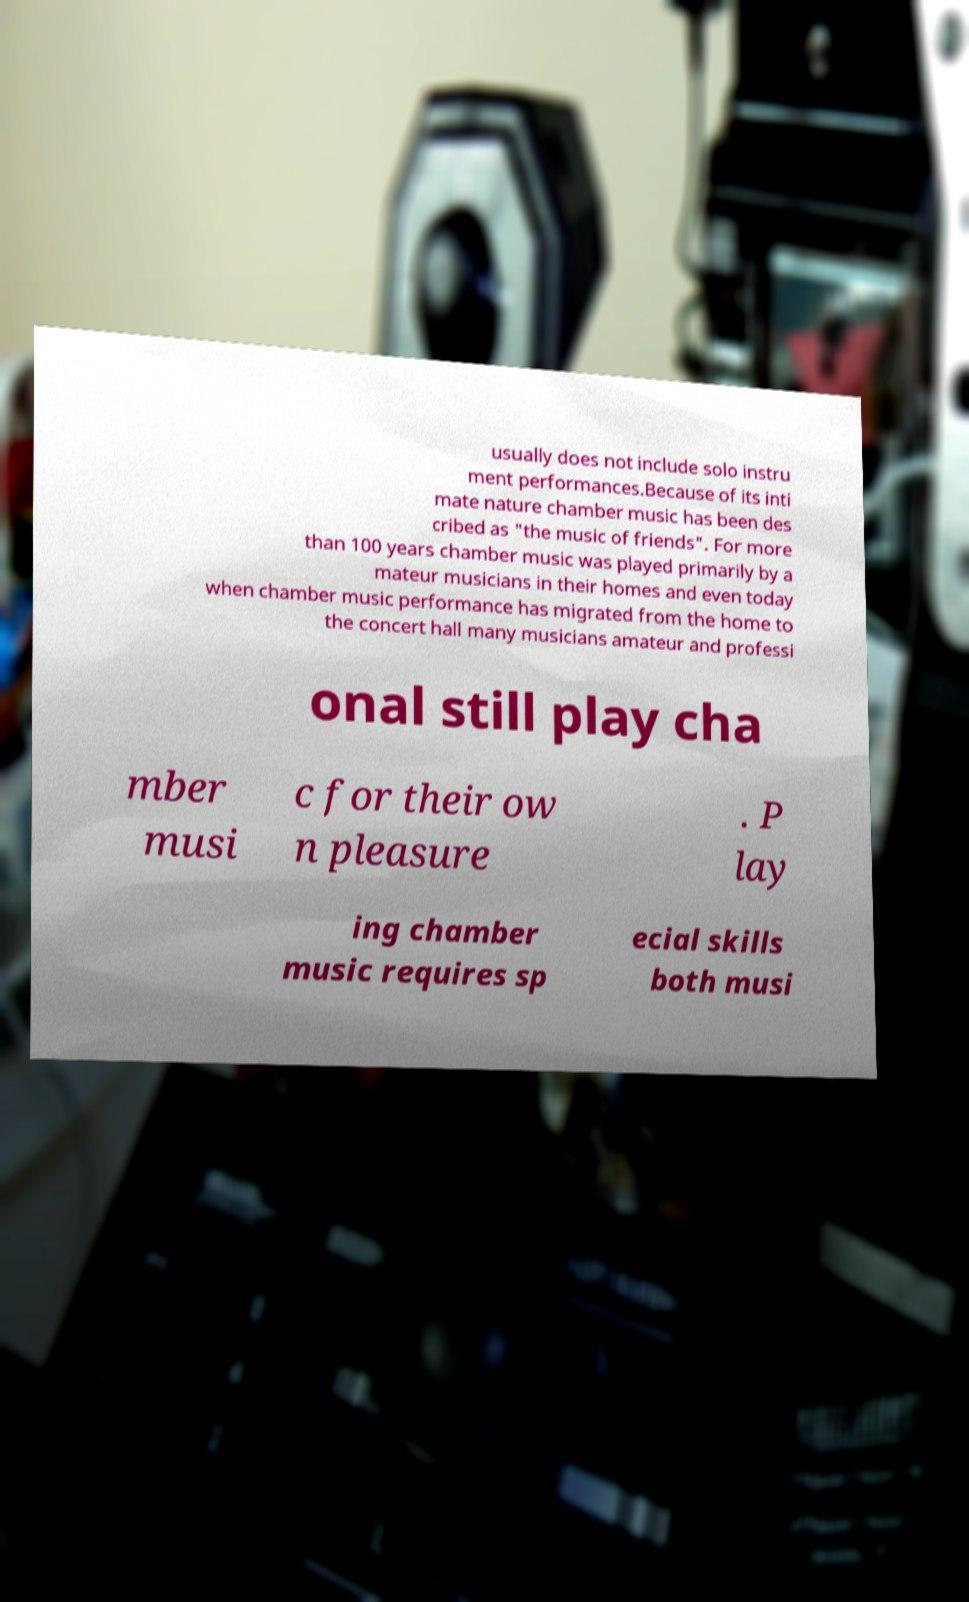There's text embedded in this image that I need extracted. Can you transcribe it verbatim? usually does not include solo instru ment performances.Because of its inti mate nature chamber music has been des cribed as "the music of friends". For more than 100 years chamber music was played primarily by a mateur musicians in their homes and even today when chamber music performance has migrated from the home to the concert hall many musicians amateur and professi onal still play cha mber musi c for their ow n pleasure . P lay ing chamber music requires sp ecial skills both musi 